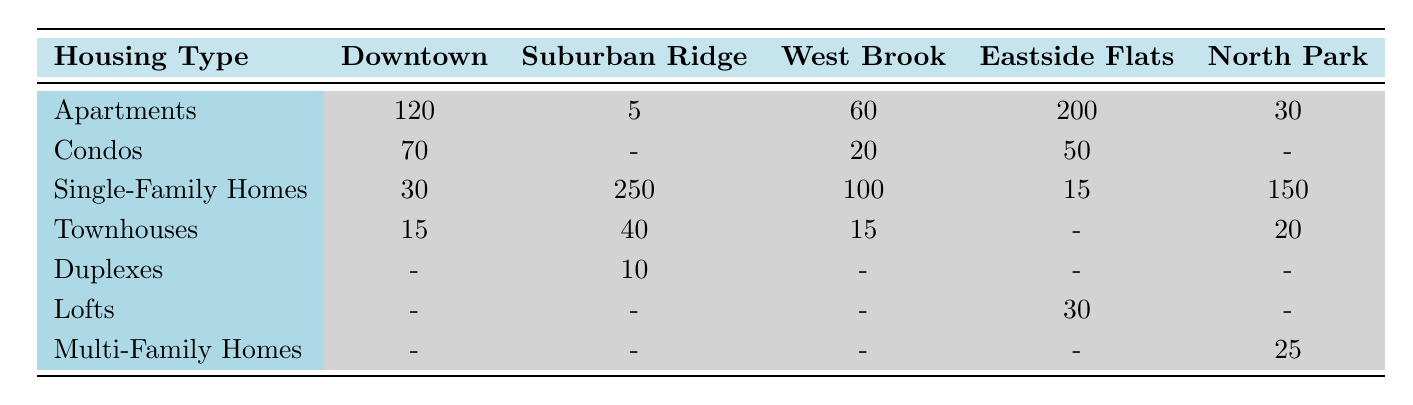What is the total number of apartments in Downtown? In Downtown, the table shows that there are 120 apartments listed.
Answer: 120 How many single-family homes are found in Suburban Ridge? The table indicates that Suburban Ridge has 250 single-family homes.
Answer: 250 What is the total number of condos across all neighborhoods? The total number of condos is calculated by adding the values from each neighborhood: 70 (Downtown) + 0 (Suburban Ridge) + 20 (West Brook) + 50 (Eastside Flats) + 0 (North Park) = 140.
Answer: 140 Is there a neighborhood with duplexes? Yes, the table shows that the only neighborhood with duplexes is Suburban Ridge, which has 10 duplexes.
Answer: Yes What is the average number of townhouses across all neighborhoods? To find the average, first, sum the townhouses: 15 (Downtown) + 40 (Suburban Ridge) + 15 (West Brook) + 0 (Eastside Flats) + 20 (North Park) = 90. Then, divide by the number of neighborhoods with data (4): 90 / 4 = 22.5.
Answer: 22.5 Which neighborhood has the highest number of apartments? By examining the table, Eastside Flats has the highest number of apartments at 200, while Downtown follows with 120 apartments.
Answer: Eastside Flats How many multi-family homes are there in North Park? North Park has 25 multi-family homes according to the table.
Answer: 25 Which housing type is most prevalent in Suburban Ridge? The most prevalent housing type in Suburban Ridge is single-family homes, with a total of 250 compared to other types listed.
Answer: Single-Family Homes What is the difference in the number of condos between Downtown and West Brook? Downtown has 70 condos and West Brook has 20 condos. The difference is calculated as 70 - 20 = 50.
Answer: 50 Which neighborhood has the least number of townhouses? According to the table, Eastside Flats has 0 townhouses, which is the least compared to other neighborhoods that have townhouses.
Answer: Eastside Flats 